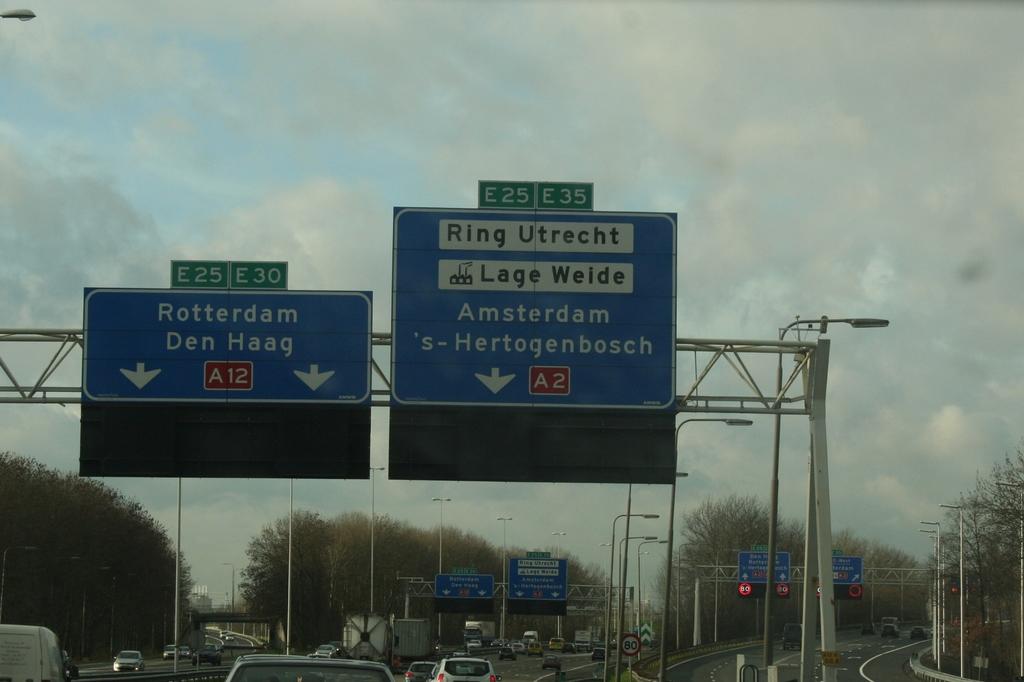What name is on the left hand sign?
Your response must be concise. Rotterdam. 